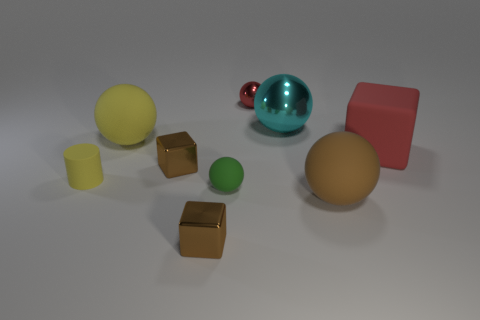Subtract all red cubes. How many cubes are left? 2 Subtract all rubber blocks. How many blocks are left? 2 Subtract all balls. How many objects are left? 4 Subtract all yellow balls. Subtract all red cubes. How many balls are left? 4 Subtract all yellow cylinders. How many gray blocks are left? 0 Subtract all blue shiny blocks. Subtract all small cylinders. How many objects are left? 8 Add 3 small spheres. How many small spheres are left? 5 Add 2 metallic cubes. How many metallic cubes exist? 4 Subtract 0 blue spheres. How many objects are left? 9 Subtract 1 balls. How many balls are left? 4 